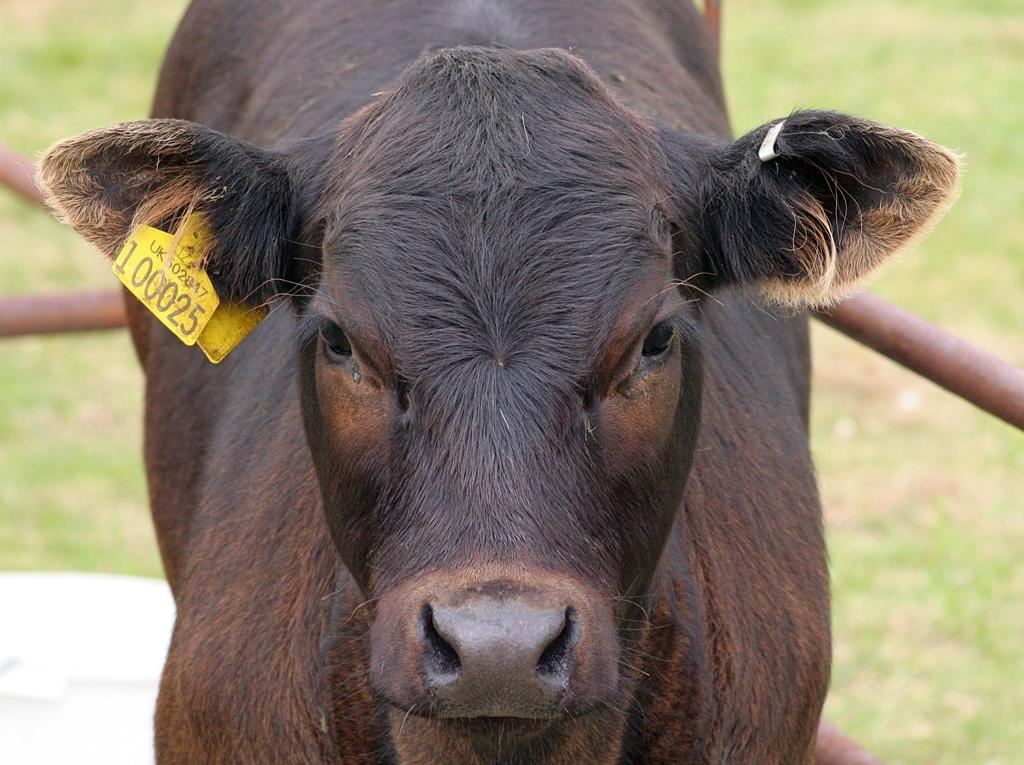What type of animal is in the image? There is a black color buffalo in the image. What is the background of the image? There is grass visible in the image. What hobbies does the buffalo enjoy in the image? The image does not provide information about the buffalo's hobbies, as it is a still image and does not show the buffalo engaging in any activities. 